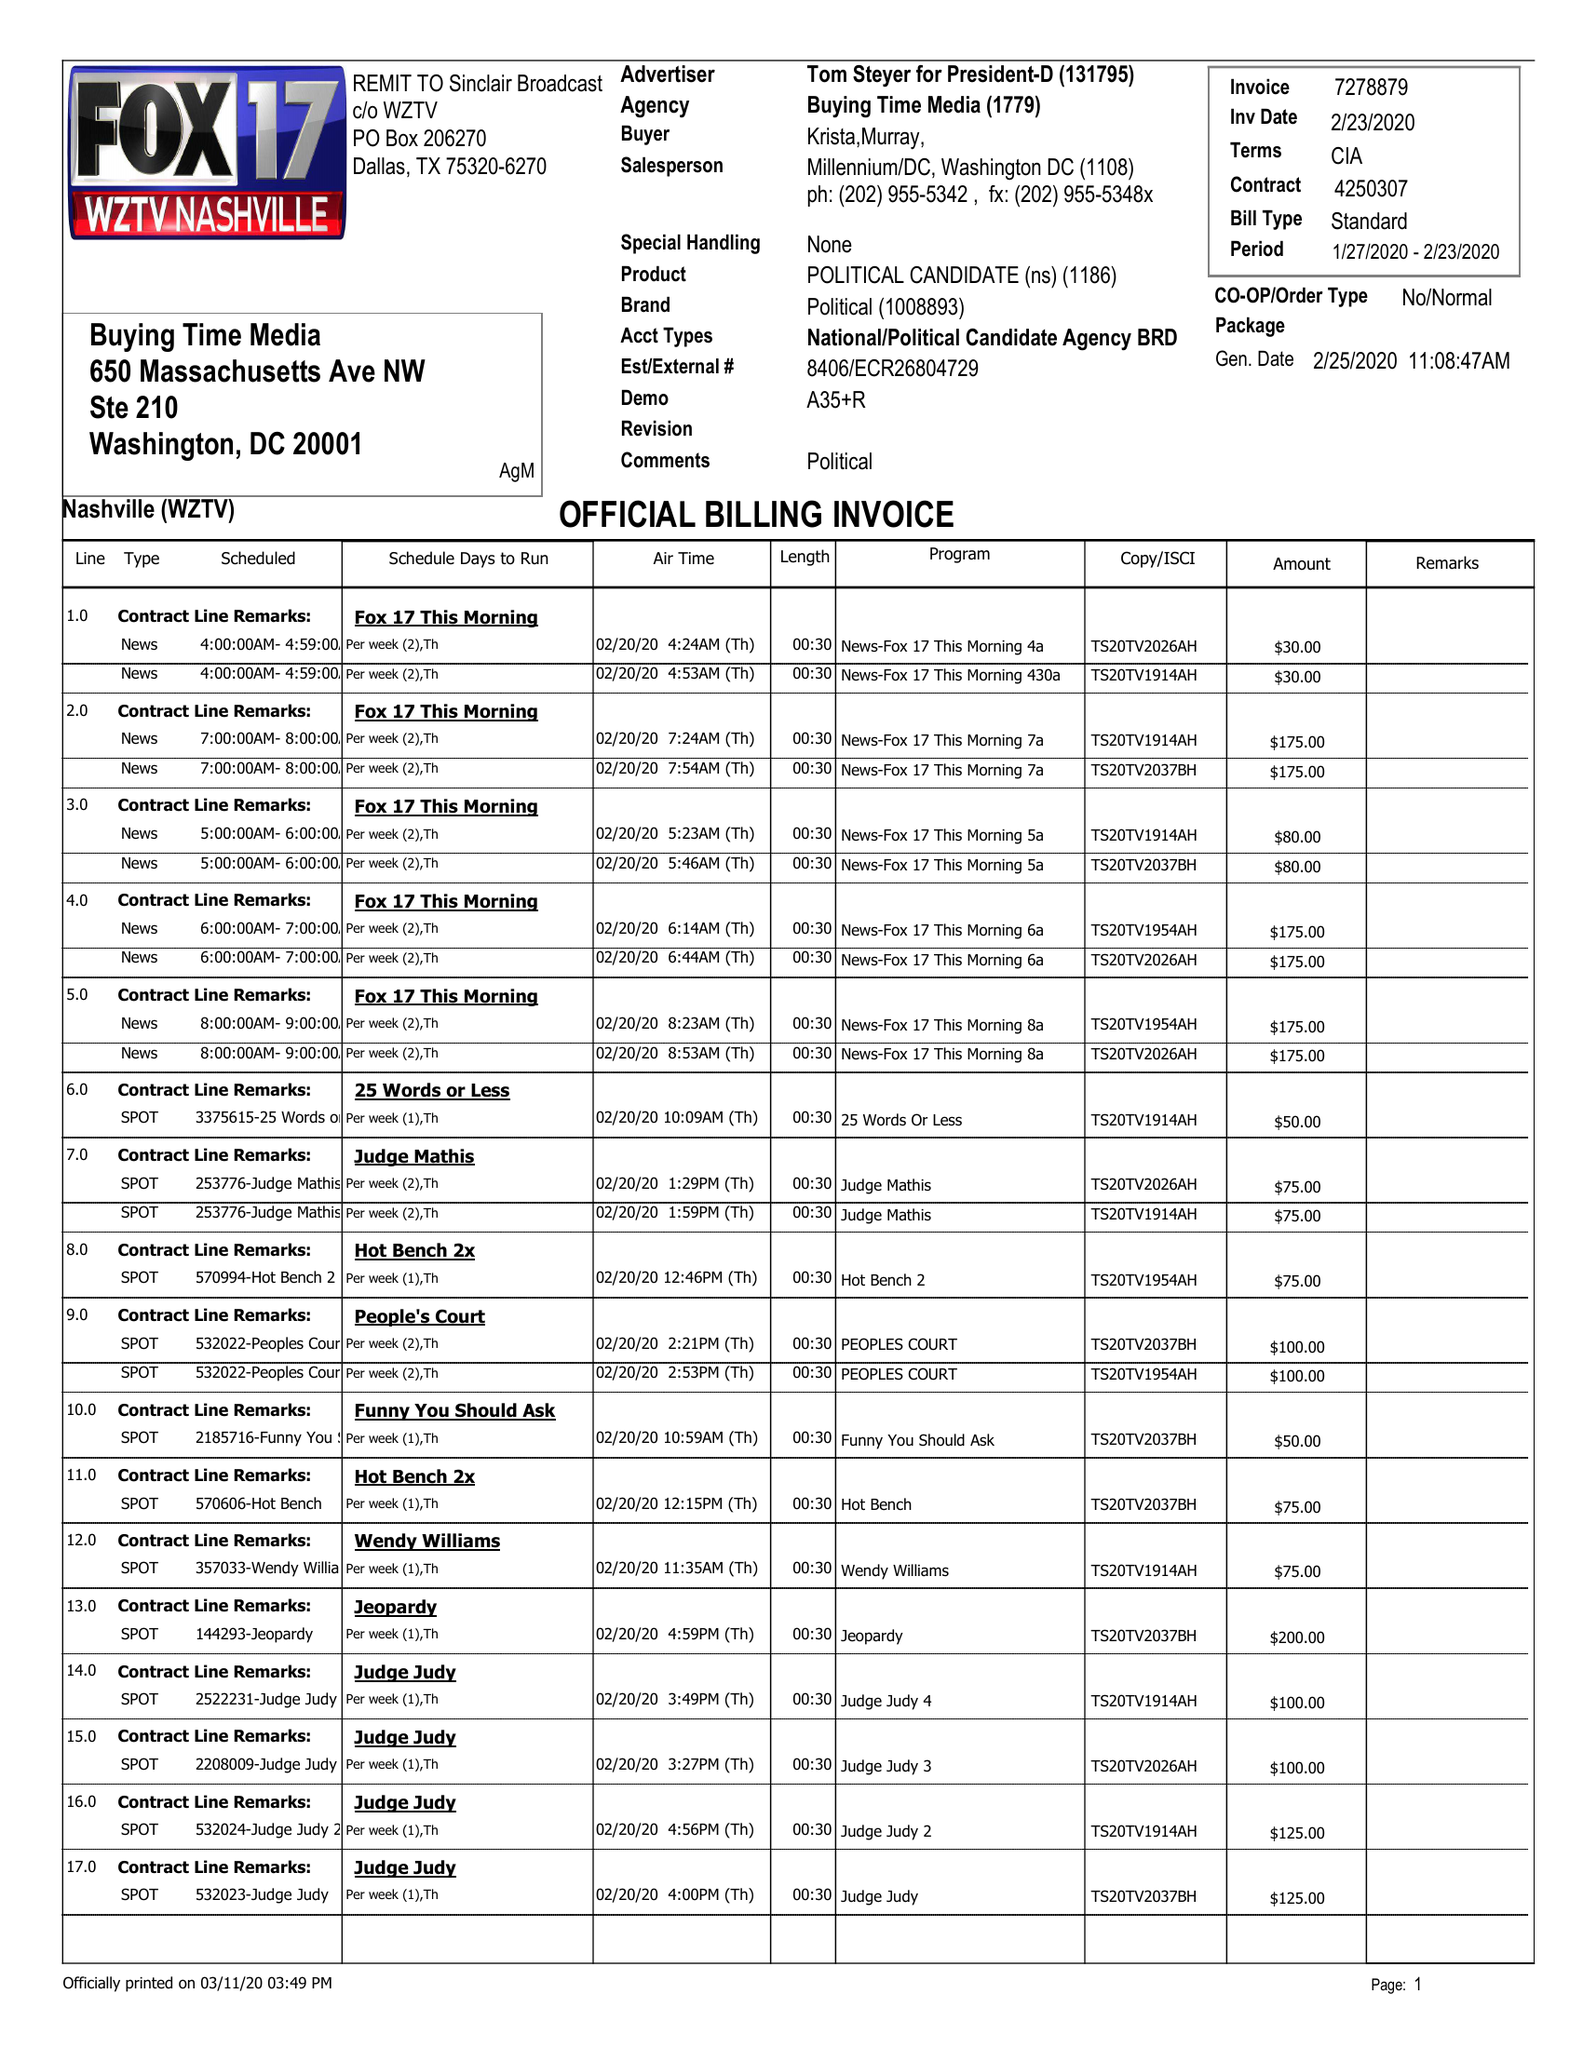What is the value for the gross_amount?
Answer the question using a single word or phrase. 5965.00 